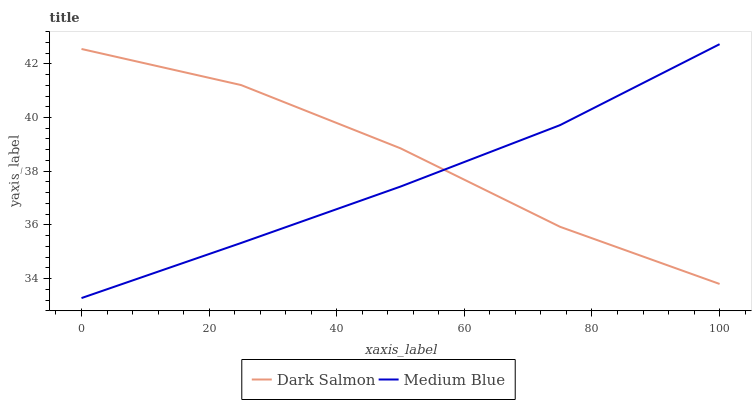Does Medium Blue have the minimum area under the curve?
Answer yes or no. Yes. Does Dark Salmon have the maximum area under the curve?
Answer yes or no. Yes. Does Dark Salmon have the minimum area under the curve?
Answer yes or no. No. Is Medium Blue the smoothest?
Answer yes or no. Yes. Is Dark Salmon the roughest?
Answer yes or no. Yes. Is Dark Salmon the smoothest?
Answer yes or no. No. Does Medium Blue have the lowest value?
Answer yes or no. Yes. Does Dark Salmon have the lowest value?
Answer yes or no. No. Does Medium Blue have the highest value?
Answer yes or no. Yes. Does Dark Salmon have the highest value?
Answer yes or no. No. Does Medium Blue intersect Dark Salmon?
Answer yes or no. Yes. Is Medium Blue less than Dark Salmon?
Answer yes or no. No. Is Medium Blue greater than Dark Salmon?
Answer yes or no. No. 